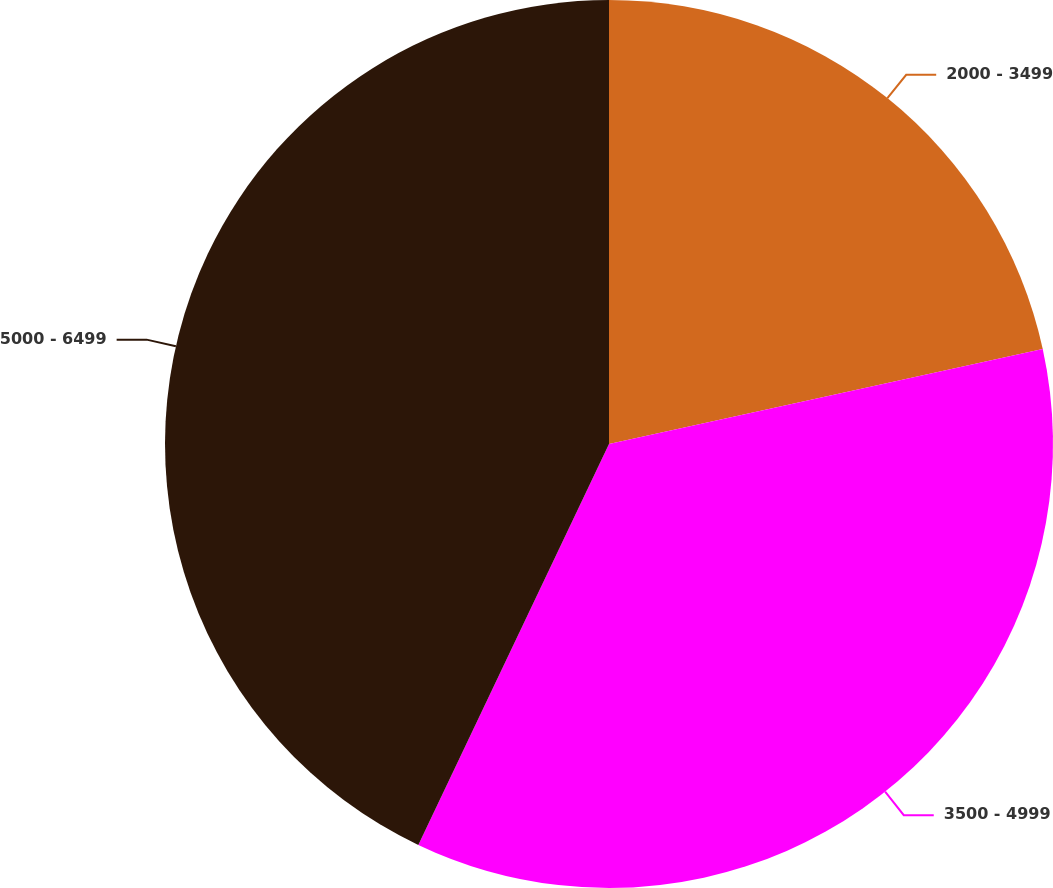<chart> <loc_0><loc_0><loc_500><loc_500><pie_chart><fcel>2000 - 3499<fcel>3500 - 4999<fcel>5000 - 6499<nl><fcel>21.57%<fcel>35.49%<fcel>42.93%<nl></chart> 